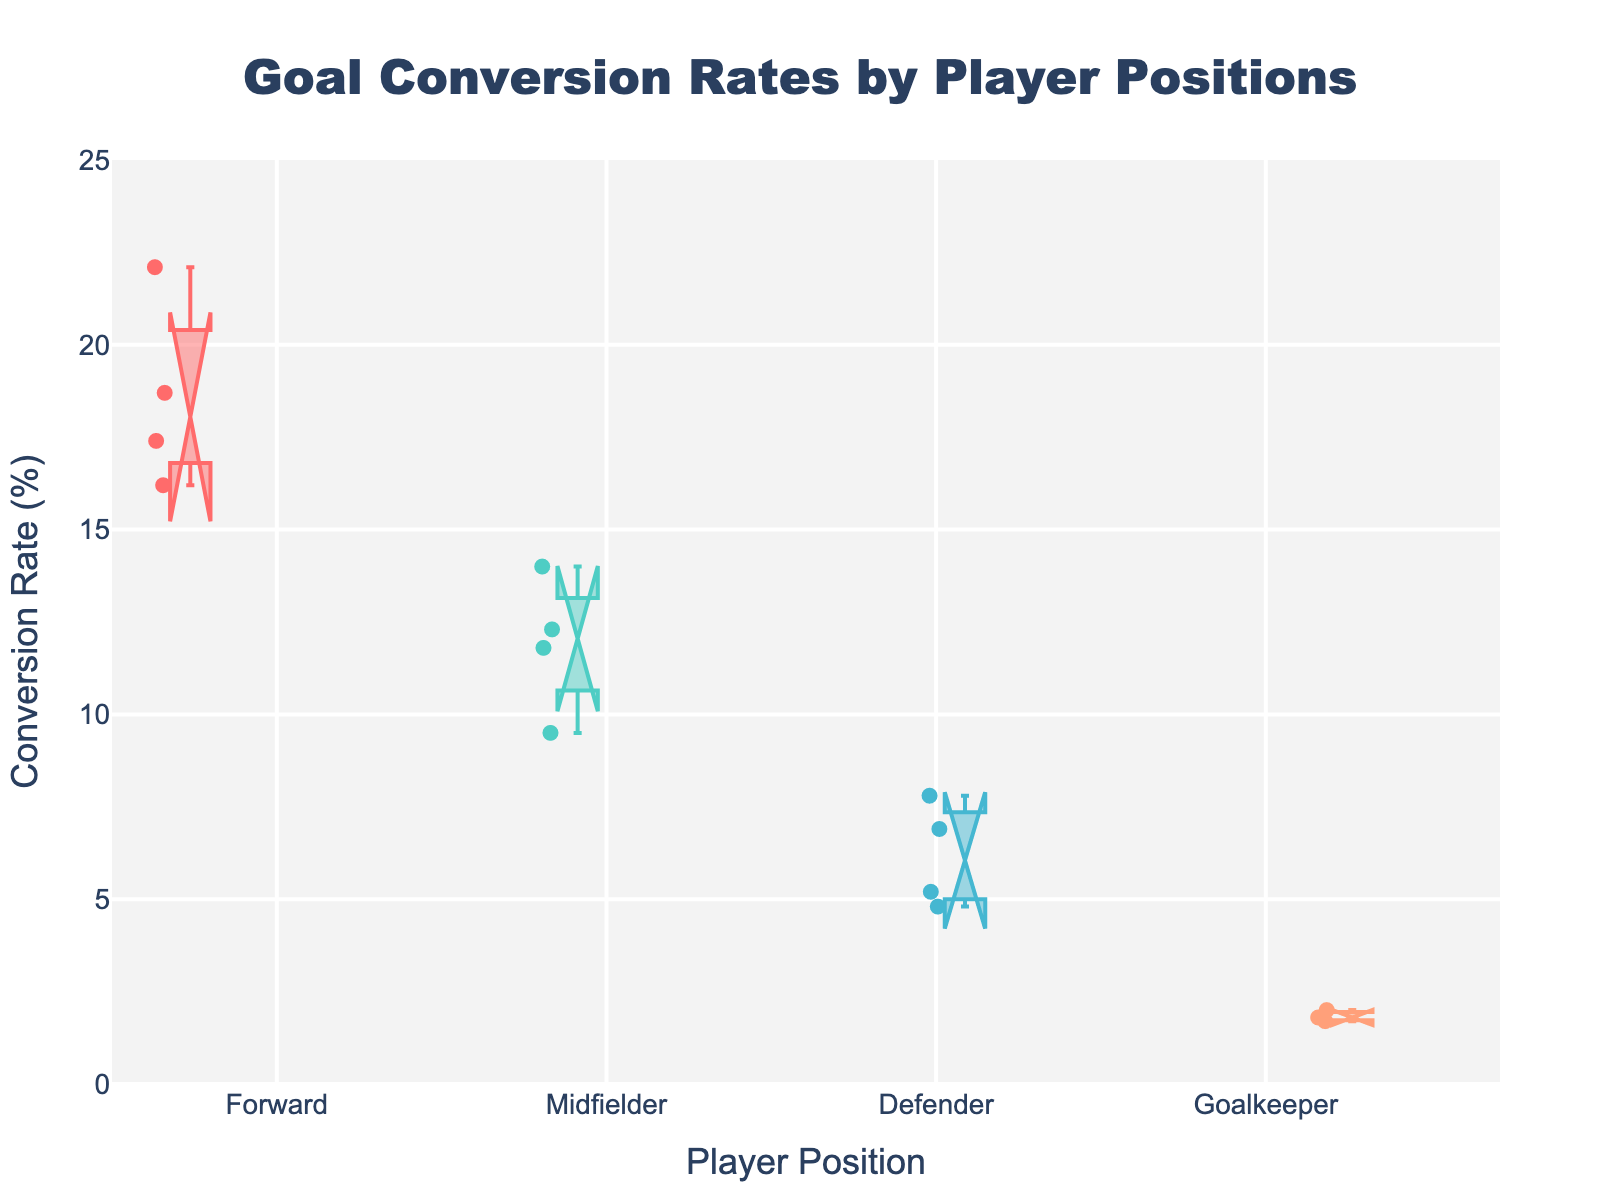What's the title of the figure? The title is often displayed at the top of the plot to give an overview of what the plot represents. It's typically highlighted and larger in font size.
Answer: Goal Conversion Rates by Player Positions Which player position has the highest median goal conversion rate? The notched box plot shows medians as the center line of the notch. The box with the highest center line is for the "Forward" position.
Answer: Forward How many data points represent the Defender position? The data points are visually indicated by the small markers within the "Defender" box plot. Count each of these markers to get the total number.
Answer: 4 Which position has the widest interquartile range (IQR)? IQR is the range from the 25th to 75th percentile, represented by the box length. Visually inspect each box and the one with the widest box length represents the "Midfielder" position.
Answer: Midfielder Does the Forward position have more variability in conversion rates than the Goalkeeper position? Variability can be seen by the length of the whiskers and the spread of the data points. The Forward box is larger and has longer whiskers compared to the smaller box and shorter whiskers of the Goalkeeper.
Answer: Yes What is unique about the notches in a notched box plot? The notches indicate the confidence interval around the median. If the notches of two separate box plots do not overlap, it suggests that the medians are statistically significantly different.
Answer: Confidence intervals Is there any overlap between notches of the Forward and Midfielder positions? Look closely at the notches of the Forward and Midfielder boxes. If they visually overlap, there is no statistical significance between their medians.
Answer: No Which position shows the lowest goal conversion rate for any player? Check the lowest data point on the plot, which is marked explicitly below each box. The lowest visible marker under the "Goalkeeper" box indicates the minimum value.
Answer: Goalkeeper What is the median conversion rate for Midfielders? The median for Midfielders is represented by the center line of their notch in the "Midfielder" box.
Answer: 12.3% Between Defenders and Goalkeepers, which position has a higher median conversion rate? The median is shown by the center line within the notch for each position's box plot. Comparing the "Defender" and "Goalkeeper" boxes, the Defender has a higher median.
Answer: Defender 